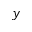Convert formula to latex. <formula><loc_0><loc_0><loc_500><loc_500>y</formula> 